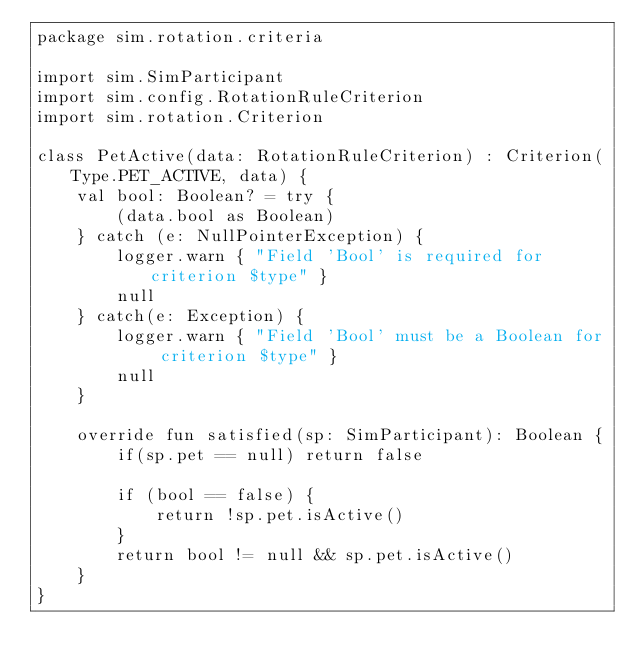<code> <loc_0><loc_0><loc_500><loc_500><_Kotlin_>package sim.rotation.criteria

import sim.SimParticipant
import sim.config.RotationRuleCriterion
import sim.rotation.Criterion

class PetActive(data: RotationRuleCriterion) : Criterion(Type.PET_ACTIVE, data) {
    val bool: Boolean? = try {
        (data.bool as Boolean)
    } catch (e: NullPointerException) {
        logger.warn { "Field 'Bool' is required for criterion $type" }
        null
    } catch(e: Exception) {
        logger.warn { "Field 'Bool' must be a Boolean for criterion $type" }
        null
    }

    override fun satisfied(sp: SimParticipant): Boolean {
        if(sp.pet == null) return false

        if (bool == false) {
            return !sp.pet.isActive()
        }
        return bool != null && sp.pet.isActive()
    }
}
</code> 